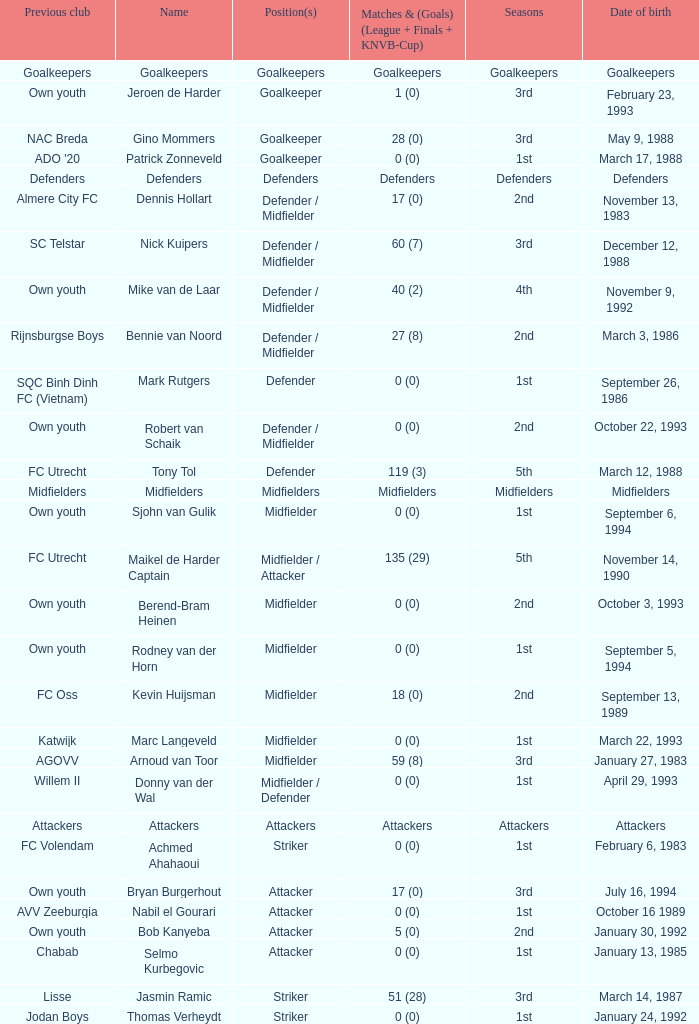What previous club was born on October 22, 1993? Own youth. 